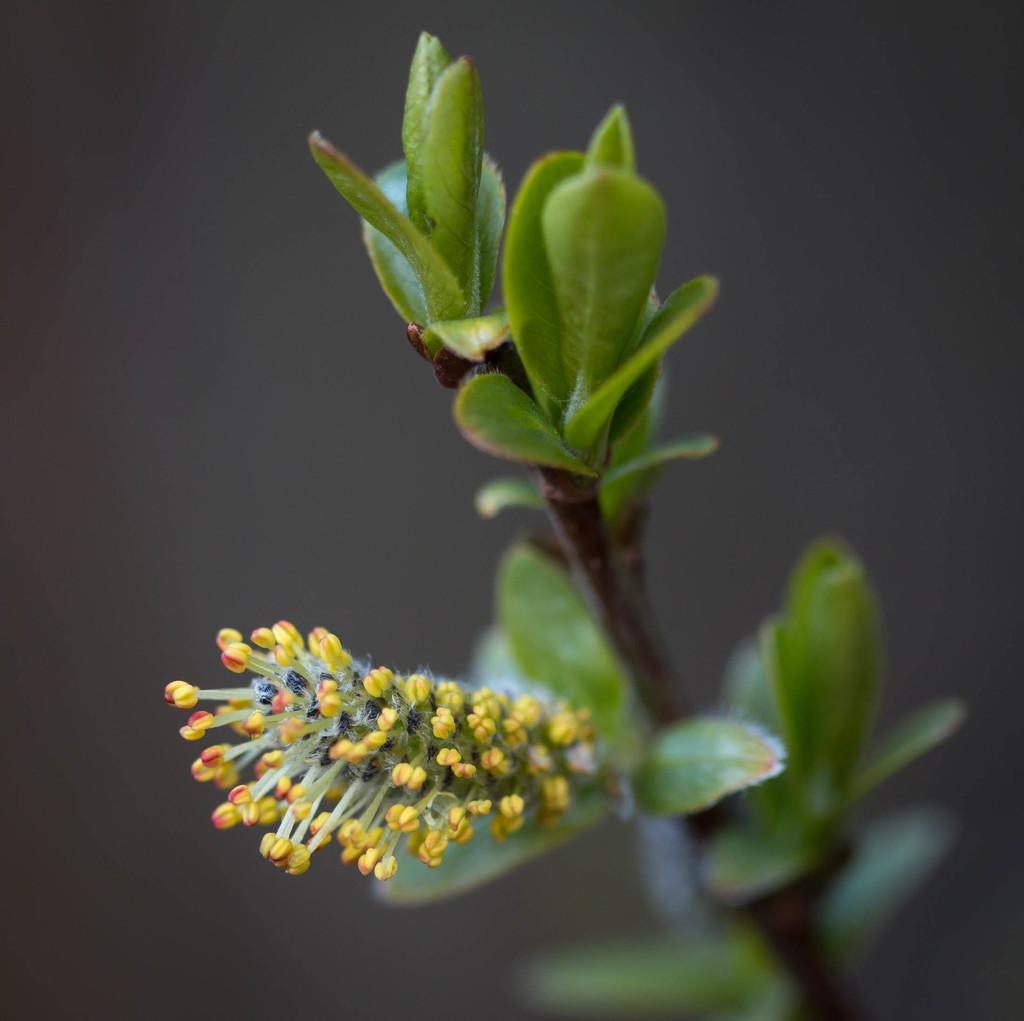Could you give a brief overview of what you see in this image? On the left side these are the buds which are in yellow color. On the right side these are the leaves of a plant. 